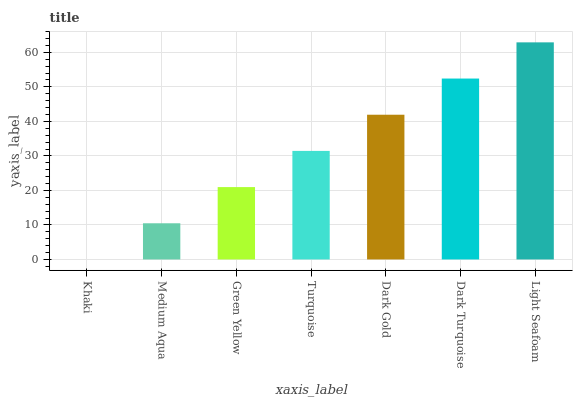Is Khaki the minimum?
Answer yes or no. Yes. Is Light Seafoam the maximum?
Answer yes or no. Yes. Is Medium Aqua the minimum?
Answer yes or no. No. Is Medium Aqua the maximum?
Answer yes or no. No. Is Medium Aqua greater than Khaki?
Answer yes or no. Yes. Is Khaki less than Medium Aqua?
Answer yes or no. Yes. Is Khaki greater than Medium Aqua?
Answer yes or no. No. Is Medium Aqua less than Khaki?
Answer yes or no. No. Is Turquoise the high median?
Answer yes or no. Yes. Is Turquoise the low median?
Answer yes or no. Yes. Is Khaki the high median?
Answer yes or no. No. Is Khaki the low median?
Answer yes or no. No. 